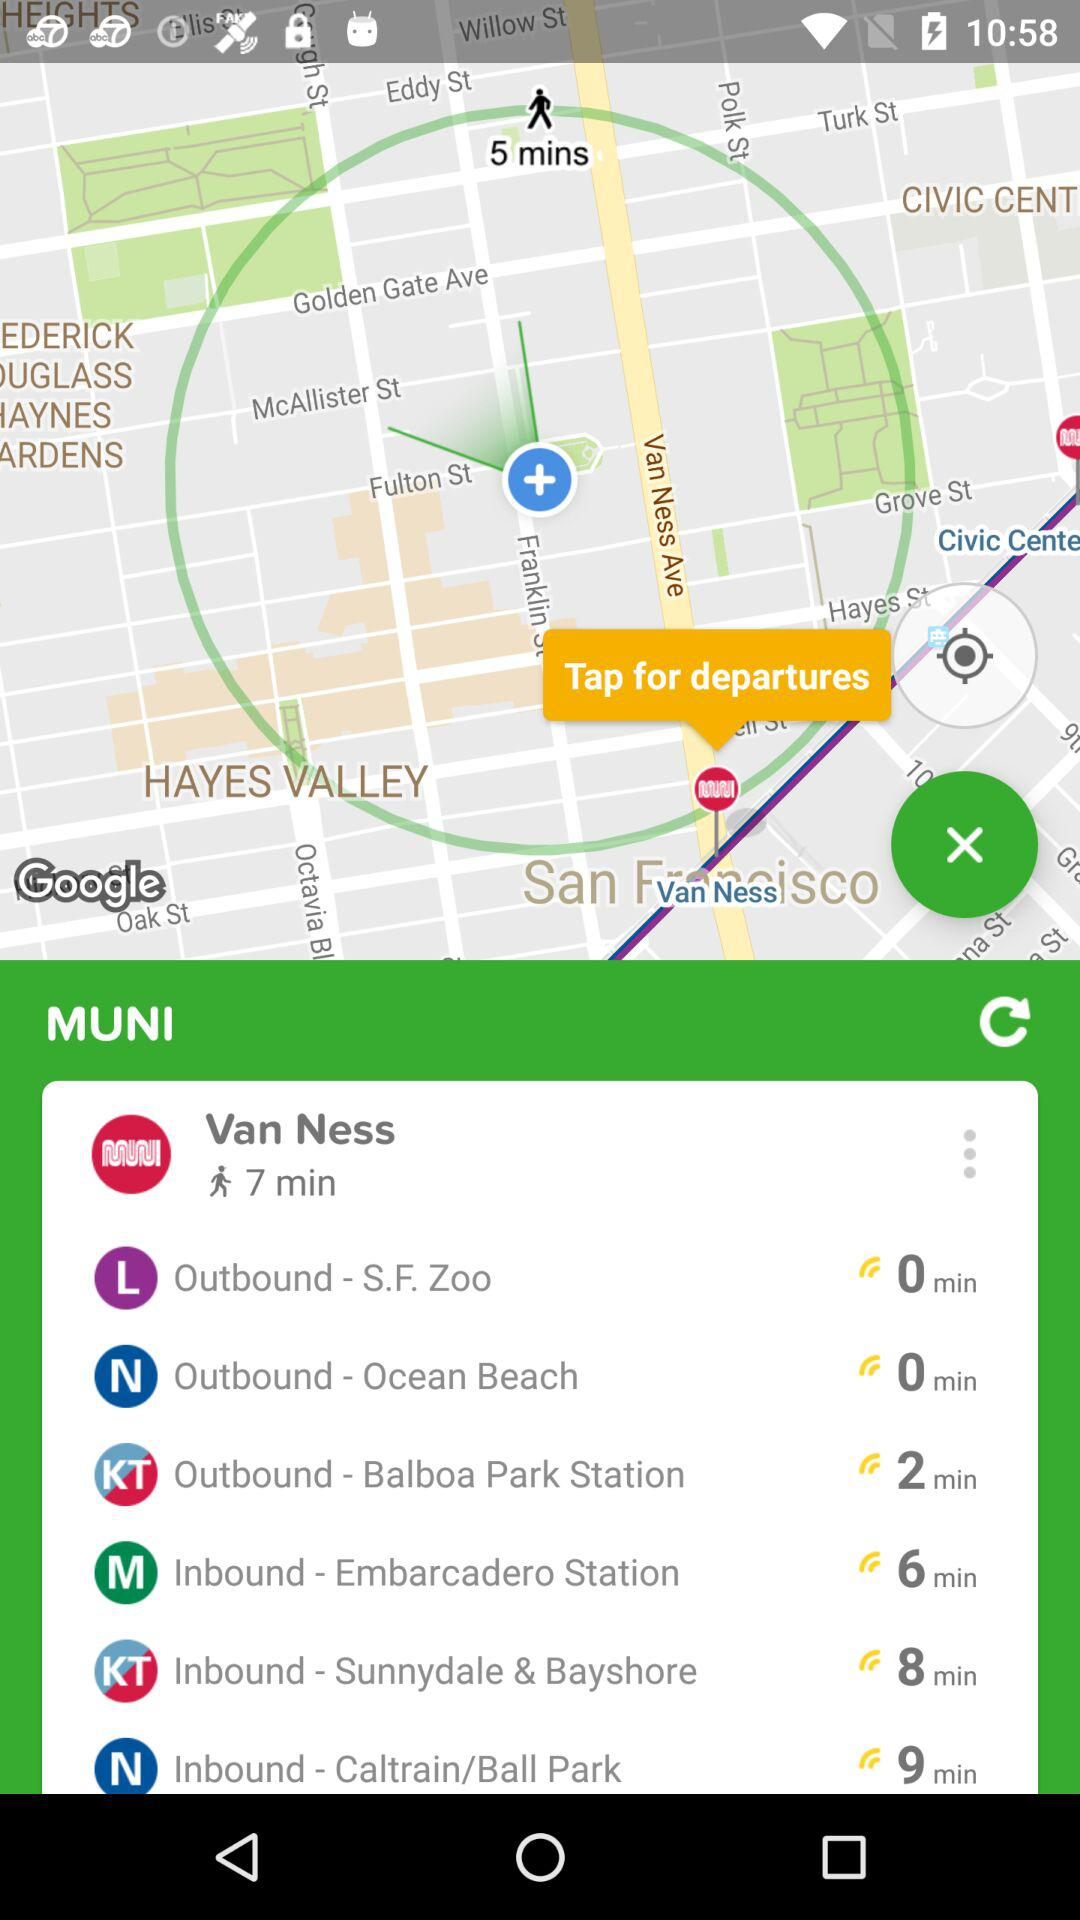How many of the departures are inbound?
Answer the question using a single word or phrase. 3 